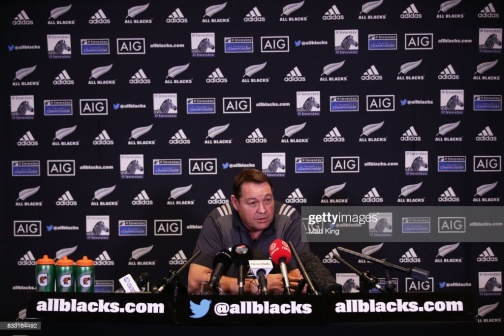Give an extremely detailed account of what's happening in the background. The background of the image is meticulously designed to maximize brand exposure and present a cohesive image of sponsorship and support for the All Blacks. The wall is covered in a grid layout featuring alternating logos, primarily the 'allblacks.com' and 'AIG' logos. These logos are interspersed with the All Blacks' iconic silver fern symbol and additional branding elements, creating a visually arresting backdrop that underscores the team's professional and corporate partnerships. The repetition and orderly arrangement of the logos contribute to a sense of organization and professionalism. This meticulously planned backdrop ensures that no matter where the camera focuses, the key sponsors receive ample visibility. Such visuals are essential in sports media events to uphold brand commitments and contractual obligations with sponsors. Based on this image, create a short and realistic scenario of what could be happening. In a short and realistic scenario, the man at the desk could be the head coach of the All Blacks, providing a pre-match briefing to the media. He's discussing the team's strategy and key players to watch in the upcoming game, answering questions from journalists about the team's preparation and addressing any last-minute changes or injuries. 